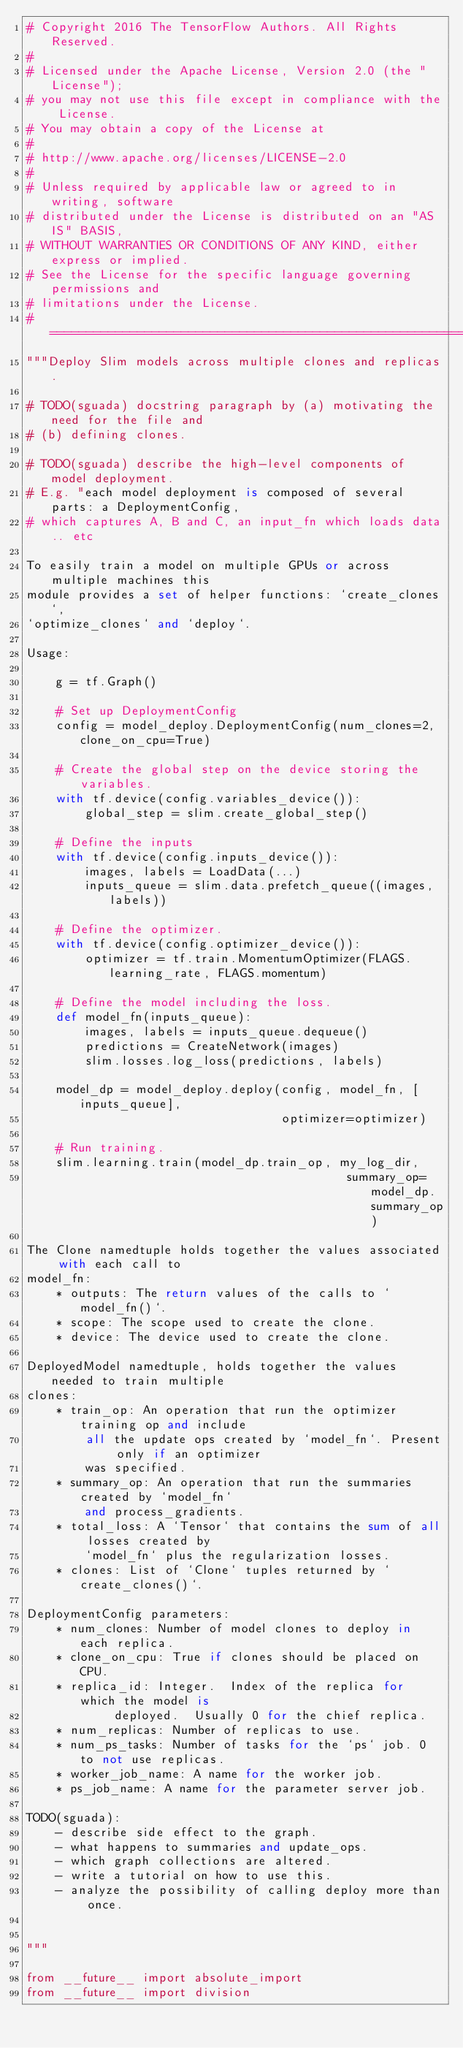Convert code to text. <code><loc_0><loc_0><loc_500><loc_500><_Python_># Copyright 2016 The TensorFlow Authors. All Rights Reserved.
#
# Licensed under the Apache License, Version 2.0 (the "License");
# you may not use this file except in compliance with the License.
# You may obtain a copy of the License at
#
# http://www.apache.org/licenses/LICENSE-2.0
#
# Unless required by applicable law or agreed to in writing, software
# distributed under the License is distributed on an "AS IS" BASIS,
# WITHOUT WARRANTIES OR CONDITIONS OF ANY KIND, either express or implied.
# See the License for the specific language governing permissions and
# limitations under the License.
# ==============================================================================
"""Deploy Slim models across multiple clones and replicas.

# TODO(sguada) docstring paragraph by (a) motivating the need for the file and
# (b) defining clones.

# TODO(sguada) describe the high-level components of model deployment.
# E.g. "each model deployment is composed of several parts: a DeploymentConfig,
# which captures A, B and C, an input_fn which loads data.. etc

To easily train a model on multiple GPUs or across multiple machines this
module provides a set of helper functions: `create_clones`,
`optimize_clones` and `deploy`.

Usage:

    g = tf.Graph()

    # Set up DeploymentConfig
    config = model_deploy.DeploymentConfig(num_clones=2, clone_on_cpu=True)

    # Create the global step on the device storing the variables.
    with tf.device(config.variables_device()):
        global_step = slim.create_global_step()

    # Define the inputs
    with tf.device(config.inputs_device()):
        images, labels = LoadData(...)
        inputs_queue = slim.data.prefetch_queue((images, labels))

    # Define the optimizer.
    with tf.device(config.optimizer_device()):
        optimizer = tf.train.MomentumOptimizer(FLAGS.learning_rate, FLAGS.momentum)

    # Define the model including the loss.
    def model_fn(inputs_queue):
        images, labels = inputs_queue.dequeue()
        predictions = CreateNetwork(images)
        slim.losses.log_loss(predictions, labels)

    model_dp = model_deploy.deploy(config, model_fn, [inputs_queue],
                                   optimizer=optimizer)

    # Run training.
    slim.learning.train(model_dp.train_op, my_log_dir,
                                            summary_op=model_dp.summary_op)

The Clone namedtuple holds together the values associated with each call to
model_fn:
    * outputs: The return values of the calls to `model_fn()`.
    * scope: The scope used to create the clone.
    * device: The device used to create the clone.

DeployedModel namedtuple, holds together the values needed to train multiple
clones:
    * train_op: An operation that run the optimizer training op and include
        all the update ops created by `model_fn`. Present only if an optimizer
        was specified.
    * summary_op: An operation that run the summaries created by `model_fn`
        and process_gradients.
    * total_loss: A `Tensor` that contains the sum of all losses created by
        `model_fn` plus the regularization losses.
    * clones: List of `Clone` tuples returned by `create_clones()`.

DeploymentConfig parameters:
    * num_clones: Number of model clones to deploy in each replica.
    * clone_on_cpu: True if clones should be placed on CPU.
    * replica_id: Integer.  Index of the replica for which the model is
            deployed.  Usually 0 for the chief replica.
    * num_replicas: Number of replicas to use.
    * num_ps_tasks: Number of tasks for the `ps` job. 0 to not use replicas.
    * worker_job_name: A name for the worker job.
    * ps_job_name: A name for the parameter server job.

TODO(sguada):
    - describe side effect to the graph.
    - what happens to summaries and update_ops.
    - which graph collections are altered.
    - write a tutorial on how to use this.
    - analyze the possibility of calling deploy more than once.


"""

from __future__ import absolute_import
from __future__ import division</code> 